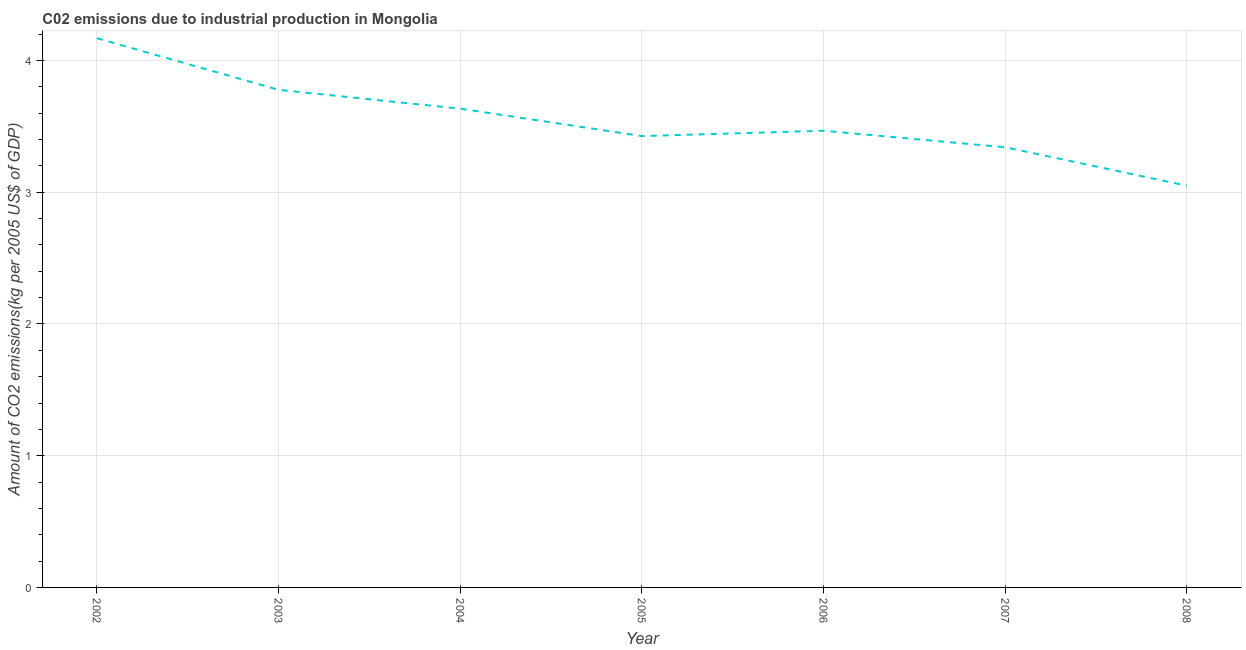What is the amount of co2 emissions in 2007?
Give a very brief answer. 3.34. Across all years, what is the maximum amount of co2 emissions?
Your answer should be compact. 4.17. Across all years, what is the minimum amount of co2 emissions?
Your answer should be compact. 3.05. In which year was the amount of co2 emissions minimum?
Offer a terse response. 2008. What is the sum of the amount of co2 emissions?
Keep it short and to the point. 24.87. What is the difference between the amount of co2 emissions in 2006 and 2007?
Ensure brevity in your answer.  0.13. What is the average amount of co2 emissions per year?
Provide a succinct answer. 3.55. What is the median amount of co2 emissions?
Give a very brief answer. 3.47. Do a majority of the years between 2005 and 2008 (inclusive) have amount of co2 emissions greater than 1 kg per 2005 US$ of GDP?
Provide a short and direct response. Yes. What is the ratio of the amount of co2 emissions in 2004 to that in 2006?
Give a very brief answer. 1.05. What is the difference between the highest and the second highest amount of co2 emissions?
Keep it short and to the point. 0.39. Is the sum of the amount of co2 emissions in 2005 and 2006 greater than the maximum amount of co2 emissions across all years?
Your answer should be very brief. Yes. What is the difference between the highest and the lowest amount of co2 emissions?
Provide a short and direct response. 1.12. In how many years, is the amount of co2 emissions greater than the average amount of co2 emissions taken over all years?
Make the answer very short. 3. Does the amount of co2 emissions monotonically increase over the years?
Give a very brief answer. No. How many lines are there?
Your answer should be very brief. 1. How many years are there in the graph?
Your answer should be compact. 7. What is the difference between two consecutive major ticks on the Y-axis?
Your answer should be compact. 1. Does the graph contain any zero values?
Give a very brief answer. No. What is the title of the graph?
Your answer should be very brief. C02 emissions due to industrial production in Mongolia. What is the label or title of the X-axis?
Your answer should be very brief. Year. What is the label or title of the Y-axis?
Your answer should be compact. Amount of CO2 emissions(kg per 2005 US$ of GDP). What is the Amount of CO2 emissions(kg per 2005 US$ of GDP) of 2002?
Ensure brevity in your answer.  4.17. What is the Amount of CO2 emissions(kg per 2005 US$ of GDP) in 2003?
Your answer should be very brief. 3.78. What is the Amount of CO2 emissions(kg per 2005 US$ of GDP) in 2004?
Give a very brief answer. 3.63. What is the Amount of CO2 emissions(kg per 2005 US$ of GDP) in 2005?
Provide a short and direct response. 3.43. What is the Amount of CO2 emissions(kg per 2005 US$ of GDP) in 2006?
Offer a terse response. 3.47. What is the Amount of CO2 emissions(kg per 2005 US$ of GDP) in 2007?
Ensure brevity in your answer.  3.34. What is the Amount of CO2 emissions(kg per 2005 US$ of GDP) in 2008?
Provide a succinct answer. 3.05. What is the difference between the Amount of CO2 emissions(kg per 2005 US$ of GDP) in 2002 and 2003?
Your answer should be very brief. 0.39. What is the difference between the Amount of CO2 emissions(kg per 2005 US$ of GDP) in 2002 and 2004?
Keep it short and to the point. 0.53. What is the difference between the Amount of CO2 emissions(kg per 2005 US$ of GDP) in 2002 and 2005?
Provide a succinct answer. 0.74. What is the difference between the Amount of CO2 emissions(kg per 2005 US$ of GDP) in 2002 and 2006?
Your answer should be very brief. 0.7. What is the difference between the Amount of CO2 emissions(kg per 2005 US$ of GDP) in 2002 and 2007?
Give a very brief answer. 0.83. What is the difference between the Amount of CO2 emissions(kg per 2005 US$ of GDP) in 2002 and 2008?
Provide a succinct answer. 1.12. What is the difference between the Amount of CO2 emissions(kg per 2005 US$ of GDP) in 2003 and 2004?
Your answer should be very brief. 0.14. What is the difference between the Amount of CO2 emissions(kg per 2005 US$ of GDP) in 2003 and 2005?
Your answer should be compact. 0.35. What is the difference between the Amount of CO2 emissions(kg per 2005 US$ of GDP) in 2003 and 2006?
Offer a very short reply. 0.31. What is the difference between the Amount of CO2 emissions(kg per 2005 US$ of GDP) in 2003 and 2007?
Ensure brevity in your answer.  0.44. What is the difference between the Amount of CO2 emissions(kg per 2005 US$ of GDP) in 2003 and 2008?
Your answer should be very brief. 0.73. What is the difference between the Amount of CO2 emissions(kg per 2005 US$ of GDP) in 2004 and 2005?
Your answer should be compact. 0.21. What is the difference between the Amount of CO2 emissions(kg per 2005 US$ of GDP) in 2004 and 2006?
Keep it short and to the point. 0.17. What is the difference between the Amount of CO2 emissions(kg per 2005 US$ of GDP) in 2004 and 2007?
Keep it short and to the point. 0.29. What is the difference between the Amount of CO2 emissions(kg per 2005 US$ of GDP) in 2004 and 2008?
Ensure brevity in your answer.  0.59. What is the difference between the Amount of CO2 emissions(kg per 2005 US$ of GDP) in 2005 and 2006?
Provide a short and direct response. -0.04. What is the difference between the Amount of CO2 emissions(kg per 2005 US$ of GDP) in 2005 and 2007?
Make the answer very short. 0.09. What is the difference between the Amount of CO2 emissions(kg per 2005 US$ of GDP) in 2005 and 2008?
Keep it short and to the point. 0.38. What is the difference between the Amount of CO2 emissions(kg per 2005 US$ of GDP) in 2006 and 2007?
Offer a terse response. 0.13. What is the difference between the Amount of CO2 emissions(kg per 2005 US$ of GDP) in 2006 and 2008?
Keep it short and to the point. 0.42. What is the difference between the Amount of CO2 emissions(kg per 2005 US$ of GDP) in 2007 and 2008?
Give a very brief answer. 0.29. What is the ratio of the Amount of CO2 emissions(kg per 2005 US$ of GDP) in 2002 to that in 2003?
Ensure brevity in your answer.  1.1. What is the ratio of the Amount of CO2 emissions(kg per 2005 US$ of GDP) in 2002 to that in 2004?
Offer a very short reply. 1.15. What is the ratio of the Amount of CO2 emissions(kg per 2005 US$ of GDP) in 2002 to that in 2005?
Offer a terse response. 1.22. What is the ratio of the Amount of CO2 emissions(kg per 2005 US$ of GDP) in 2002 to that in 2006?
Provide a succinct answer. 1.2. What is the ratio of the Amount of CO2 emissions(kg per 2005 US$ of GDP) in 2002 to that in 2007?
Your answer should be compact. 1.25. What is the ratio of the Amount of CO2 emissions(kg per 2005 US$ of GDP) in 2002 to that in 2008?
Your response must be concise. 1.37. What is the ratio of the Amount of CO2 emissions(kg per 2005 US$ of GDP) in 2003 to that in 2004?
Keep it short and to the point. 1.04. What is the ratio of the Amount of CO2 emissions(kg per 2005 US$ of GDP) in 2003 to that in 2005?
Ensure brevity in your answer.  1.1. What is the ratio of the Amount of CO2 emissions(kg per 2005 US$ of GDP) in 2003 to that in 2006?
Provide a succinct answer. 1.09. What is the ratio of the Amount of CO2 emissions(kg per 2005 US$ of GDP) in 2003 to that in 2007?
Ensure brevity in your answer.  1.13. What is the ratio of the Amount of CO2 emissions(kg per 2005 US$ of GDP) in 2003 to that in 2008?
Your response must be concise. 1.24. What is the ratio of the Amount of CO2 emissions(kg per 2005 US$ of GDP) in 2004 to that in 2005?
Make the answer very short. 1.06. What is the ratio of the Amount of CO2 emissions(kg per 2005 US$ of GDP) in 2004 to that in 2006?
Offer a very short reply. 1.05. What is the ratio of the Amount of CO2 emissions(kg per 2005 US$ of GDP) in 2004 to that in 2007?
Keep it short and to the point. 1.09. What is the ratio of the Amount of CO2 emissions(kg per 2005 US$ of GDP) in 2004 to that in 2008?
Make the answer very short. 1.19. What is the ratio of the Amount of CO2 emissions(kg per 2005 US$ of GDP) in 2005 to that in 2006?
Offer a terse response. 0.99. What is the ratio of the Amount of CO2 emissions(kg per 2005 US$ of GDP) in 2005 to that in 2007?
Your answer should be compact. 1.02. What is the ratio of the Amount of CO2 emissions(kg per 2005 US$ of GDP) in 2005 to that in 2008?
Offer a very short reply. 1.12. What is the ratio of the Amount of CO2 emissions(kg per 2005 US$ of GDP) in 2006 to that in 2007?
Provide a succinct answer. 1.04. What is the ratio of the Amount of CO2 emissions(kg per 2005 US$ of GDP) in 2006 to that in 2008?
Your answer should be compact. 1.14. What is the ratio of the Amount of CO2 emissions(kg per 2005 US$ of GDP) in 2007 to that in 2008?
Offer a very short reply. 1.1. 